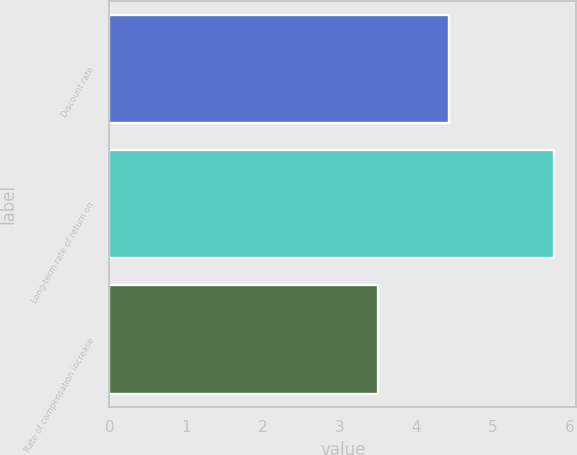Convert chart. <chart><loc_0><loc_0><loc_500><loc_500><bar_chart><fcel>Discount rate<fcel>Long-term rate of return on<fcel>Rate of compensation increase<nl><fcel>4.43<fcel>5.8<fcel>3.51<nl></chart> 